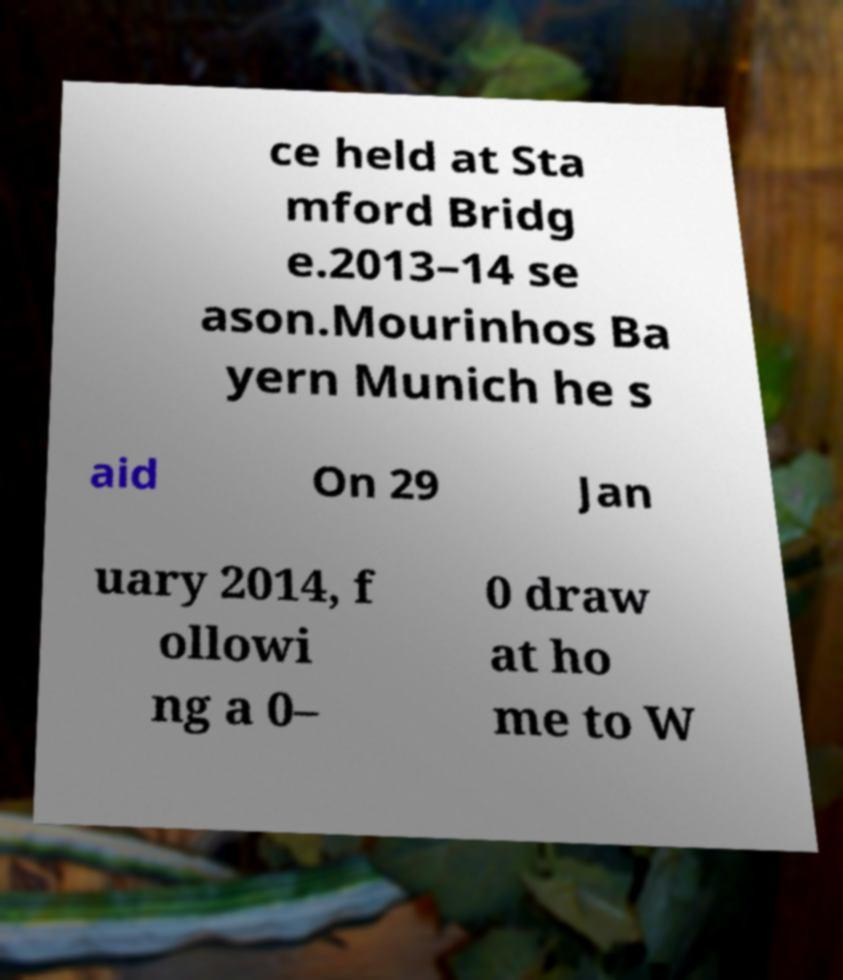For documentation purposes, I need the text within this image transcribed. Could you provide that? ce held at Sta mford Bridg e.2013–14 se ason.Mourinhos Ba yern Munich he s aid On 29 Jan uary 2014, f ollowi ng a 0– 0 draw at ho me to W 